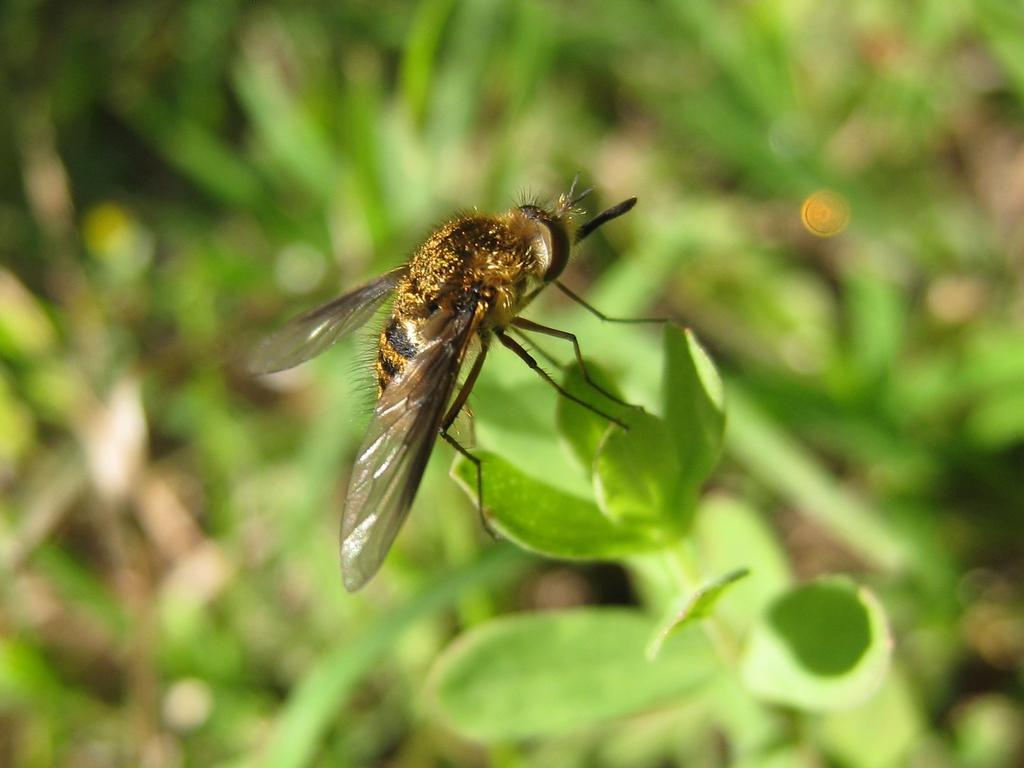What type of insect is in the image? There is a honey bee in the image. Where is the honey bee located? The honey bee is on a leaf. What can be seen in the background of the image? There are leaves visible in the background of the image. What type of stick does the honey bee's dad use to collect nectar in the image? There is no mention of a stick or the honey bee's dad in the image, as it only features a honey bee on a leaf. 